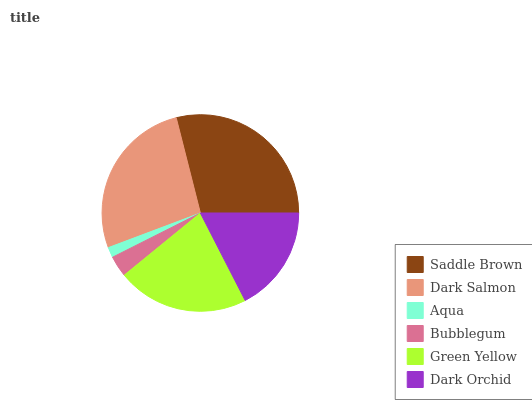Is Aqua the minimum?
Answer yes or no. Yes. Is Saddle Brown the maximum?
Answer yes or no. Yes. Is Dark Salmon the minimum?
Answer yes or no. No. Is Dark Salmon the maximum?
Answer yes or no. No. Is Saddle Brown greater than Dark Salmon?
Answer yes or no. Yes. Is Dark Salmon less than Saddle Brown?
Answer yes or no. Yes. Is Dark Salmon greater than Saddle Brown?
Answer yes or no. No. Is Saddle Brown less than Dark Salmon?
Answer yes or no. No. Is Green Yellow the high median?
Answer yes or no. Yes. Is Dark Orchid the low median?
Answer yes or no. Yes. Is Saddle Brown the high median?
Answer yes or no. No. Is Bubblegum the low median?
Answer yes or no. No. 